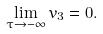<formula> <loc_0><loc_0><loc_500><loc_500>\lim _ { \tau \rightarrow - \infty } v _ { 3 } = 0 .</formula> 